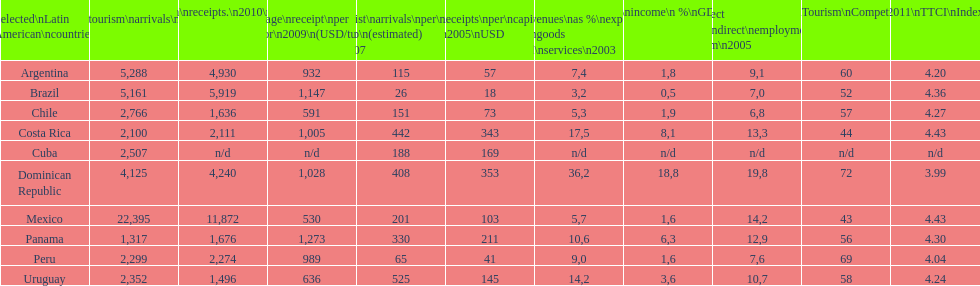Which country appears at the end of this chart? Uruguay. 